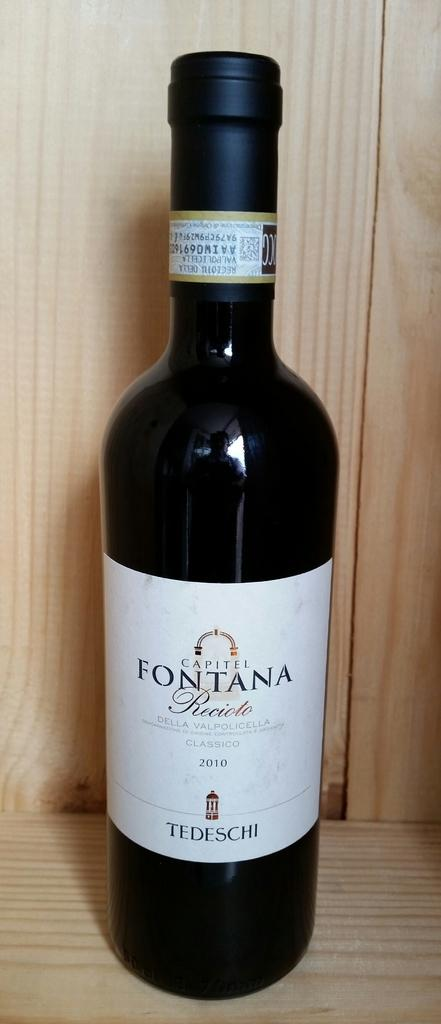<image>
Describe the image concisely. A bottle of Capitel Fontana Recioto wine is on a light colored, wooden shelf. 